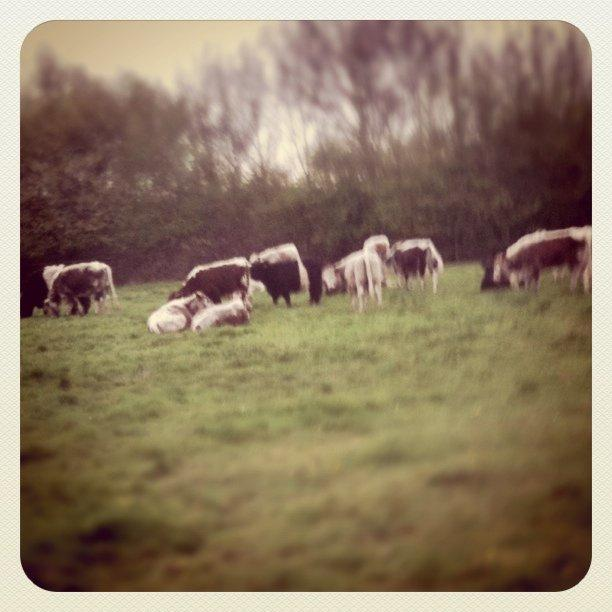What is wrong with this image?

Choices:
A) blurry
B) too close
C) too far
D) broken blurry 